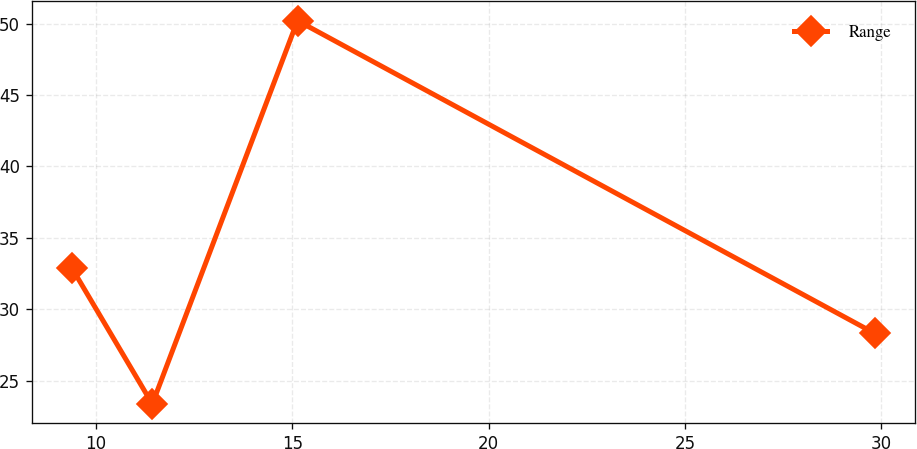<chart> <loc_0><loc_0><loc_500><loc_500><line_chart><ecel><fcel>Range<nl><fcel>9.38<fcel>32.89<nl><fcel>11.43<fcel>23.37<nl><fcel>15.13<fcel>50.2<nl><fcel>29.84<fcel>28.31<nl></chart> 